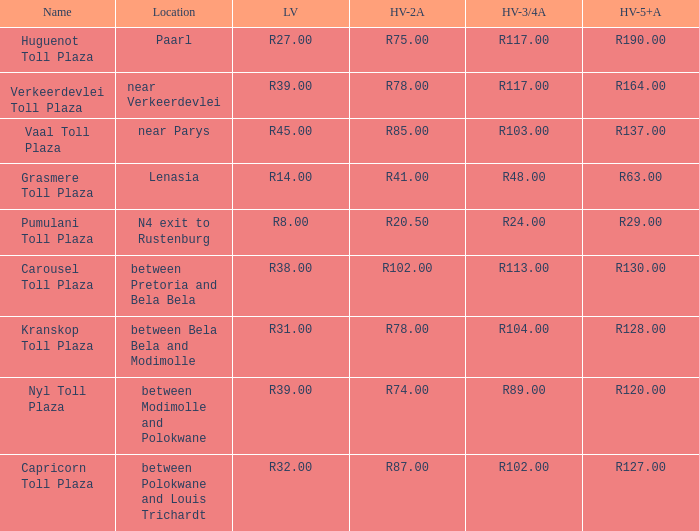What is the toll for light vehicles at the plaza between bela bela and modimolle? R31.00. 